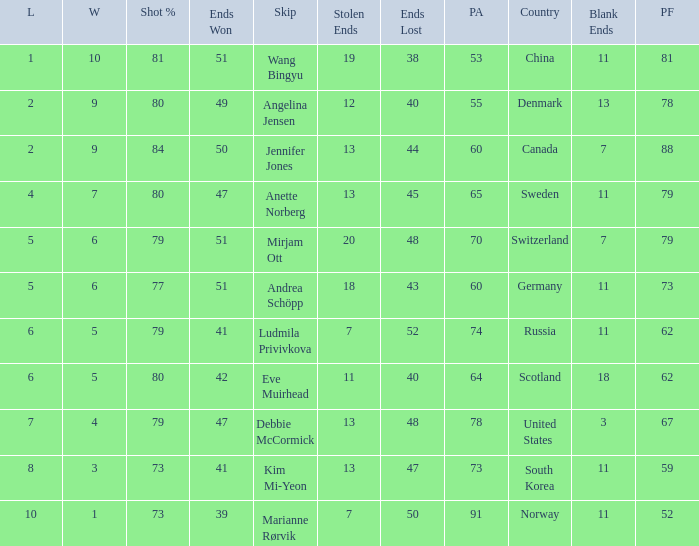What is Norway's least ends lost? 50.0. 